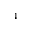Convert formula to latex. <formula><loc_0><loc_0><loc_500><loc_500>_ { 4 }</formula> 